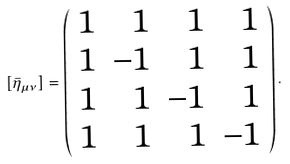<formula> <loc_0><loc_0><loc_500><loc_500>[ \bar { \eta } _ { \mu \nu } ] = \left ( \begin{array} { r r r r } 1 & 1 & 1 & 1 \\ 1 & - 1 & 1 & 1 \\ 1 & 1 & - 1 & 1 \\ 1 & 1 & 1 & - 1 \\ \end{array} \right ) .</formula> 